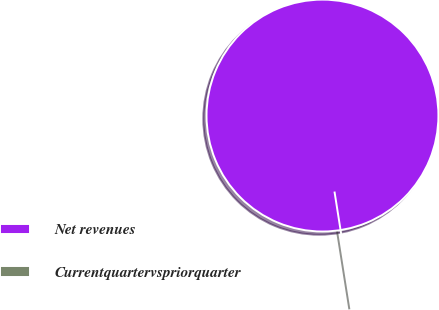<chart> <loc_0><loc_0><loc_500><loc_500><pie_chart><fcel>Net revenues<fcel>Currentquartervspriorquarter<nl><fcel>100.0%<fcel>0.0%<nl></chart> 